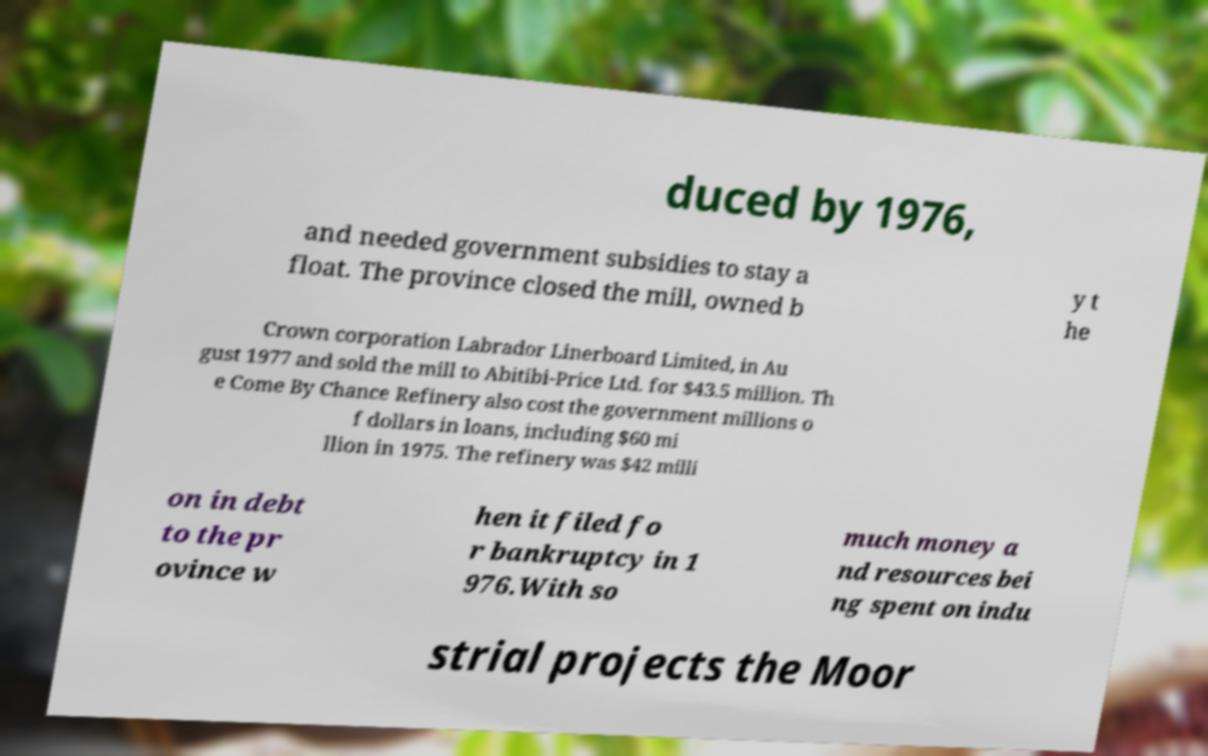Can you read and provide the text displayed in the image?This photo seems to have some interesting text. Can you extract and type it out for me? duced by 1976, and needed government subsidies to stay a float. The province closed the mill, owned b y t he Crown corporation Labrador Linerboard Limited, in Au gust 1977 and sold the mill to Abitibi-Price Ltd. for $43.5 million. Th e Come By Chance Refinery also cost the government millions o f dollars in loans, including $60 mi llion in 1975. The refinery was $42 milli on in debt to the pr ovince w hen it filed fo r bankruptcy in 1 976.With so much money a nd resources bei ng spent on indu strial projects the Moor 